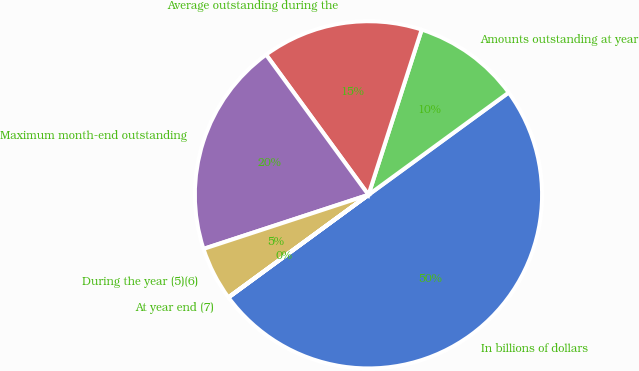<chart> <loc_0><loc_0><loc_500><loc_500><pie_chart><fcel>In billions of dollars<fcel>Amounts outstanding at year<fcel>Average outstanding during the<fcel>Maximum month-end outstanding<fcel>During the year (5)(6)<fcel>At year end (7)<nl><fcel>49.96%<fcel>10.01%<fcel>15.0%<fcel>20.0%<fcel>5.01%<fcel>0.02%<nl></chart> 